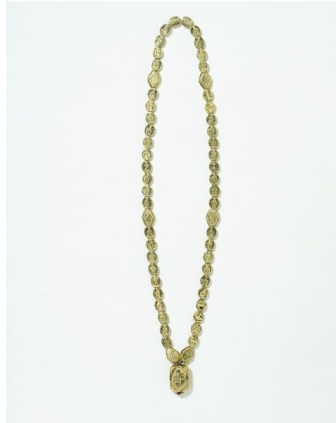What specific materials do you think make up the necklace? The necklace appears to be made of high-quality gold, given its rich golden hue. The beads are likely to be gold-plated or made from solid gold, while the pendant might be crafted from the sharegpt4v/same material and engraved with an intricate floral pattern. The overall craftsmanship suggests that premium materials were used to ensure durability and an exquisite finish. Imagine the necklace is a family heirloom. How might it be cared for over generations? As a family heirloom, the necklace would be cherished and meticulously cared for by successive generations. It would be stored in a velvet-lined jewelry box to prevent scratches, away from direct sunlight and moisture to protect its sheen. Occasionally, it would be gently cleaned with a soft cloth and a mild jewelry cleaner to maintain its luster. Grandchildren might hear stories of its origin, how it symbolized steadfast love and unity, and it would be worn with pride during family gatherings and important events, continuing its legacy of elegance and tradition. If the necklace could speak, what advice would it give to its wearers? If the necklace could speak, it would whisper to its wearers: 'Wear me with pride and elegance, for I carry the tales of love and unity built over generations. Cherish the moments I adorn you, for in each memory, I gather strength and beauty. Handle me with care, and let my golden glow reflect the light of your joy and celebrations. Remember, true elegance lies not just in adornment, but in the grace and poise with which you carry yourself in the world.' 